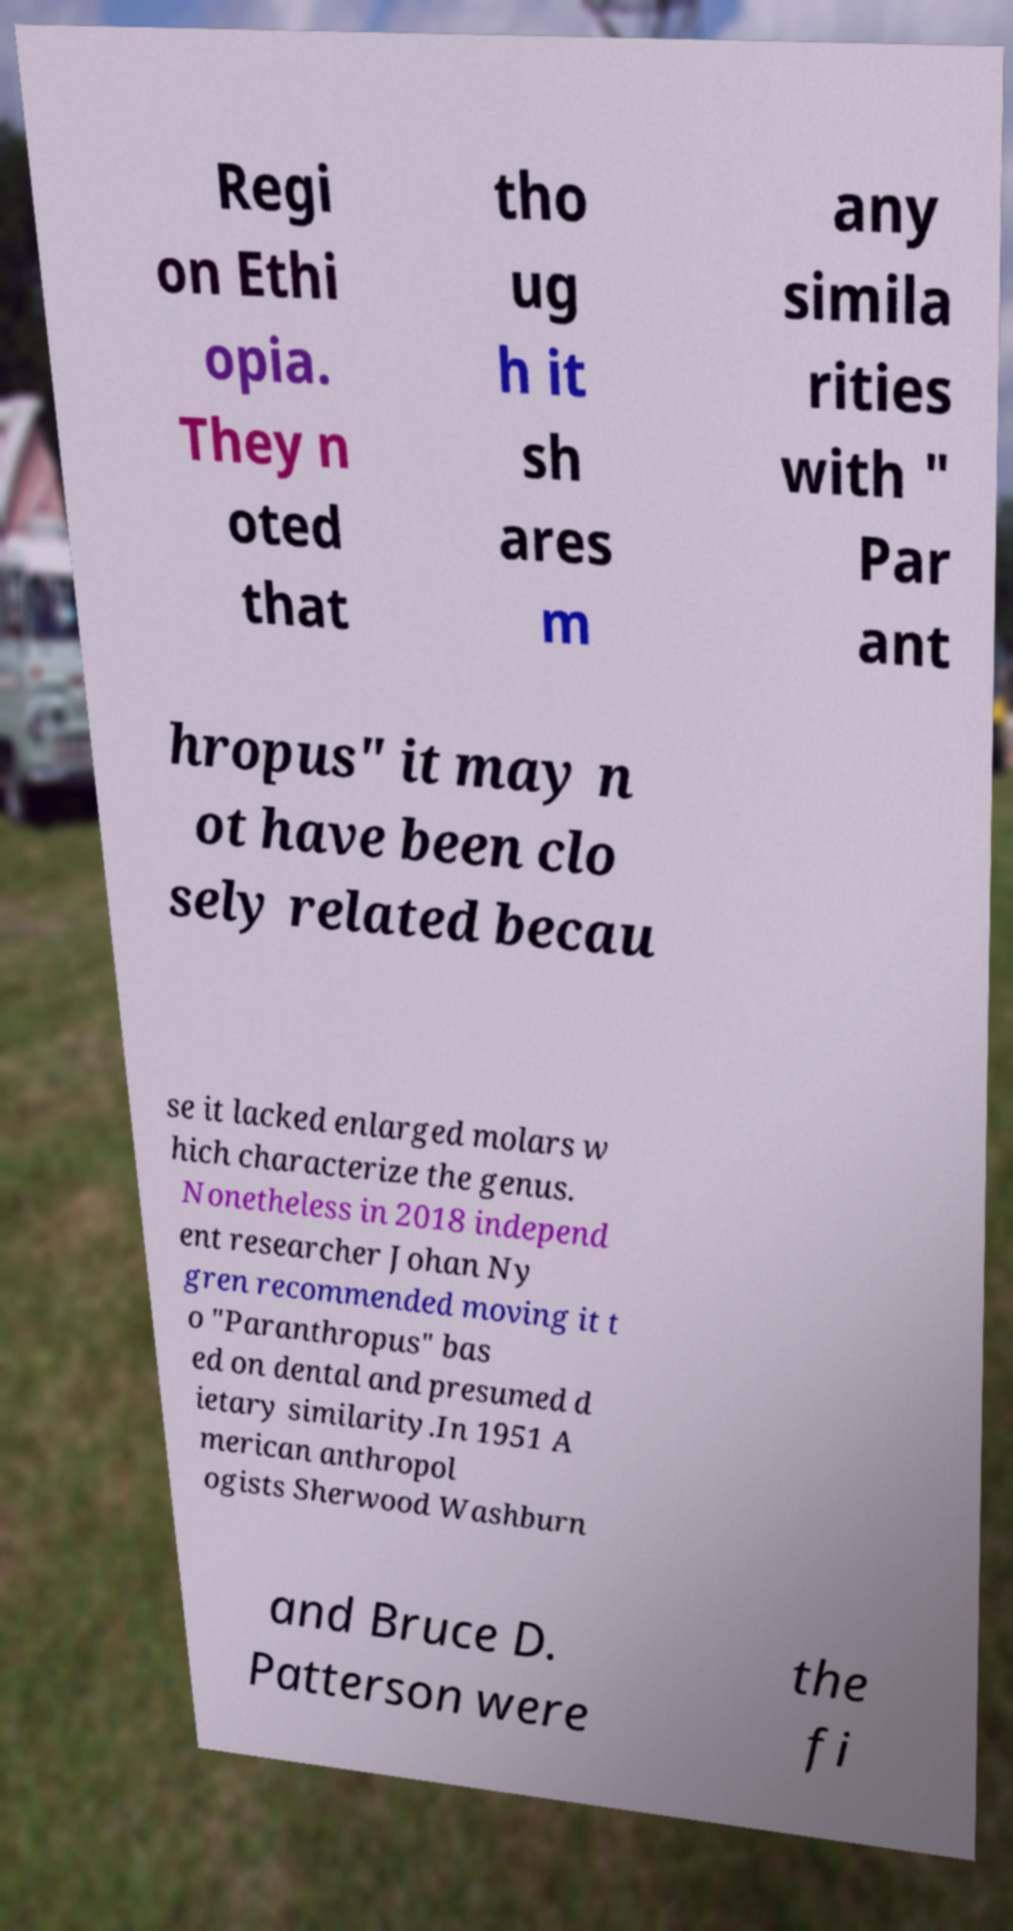For documentation purposes, I need the text within this image transcribed. Could you provide that? Regi on Ethi opia. They n oted that tho ug h it sh ares m any simila rities with " Par ant hropus" it may n ot have been clo sely related becau se it lacked enlarged molars w hich characterize the genus. Nonetheless in 2018 independ ent researcher Johan Ny gren recommended moving it t o "Paranthropus" bas ed on dental and presumed d ietary similarity.In 1951 A merican anthropol ogists Sherwood Washburn and Bruce D. Patterson were the fi 